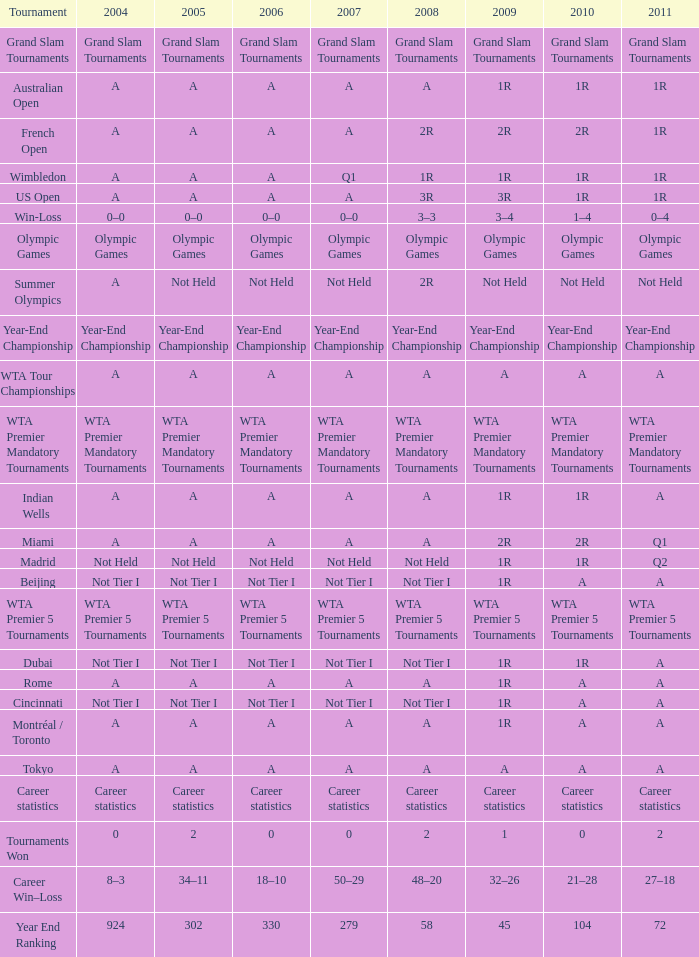What is 2004, when 2005 is "Not Tier I"? Not Tier I, Not Tier I, Not Tier I. 